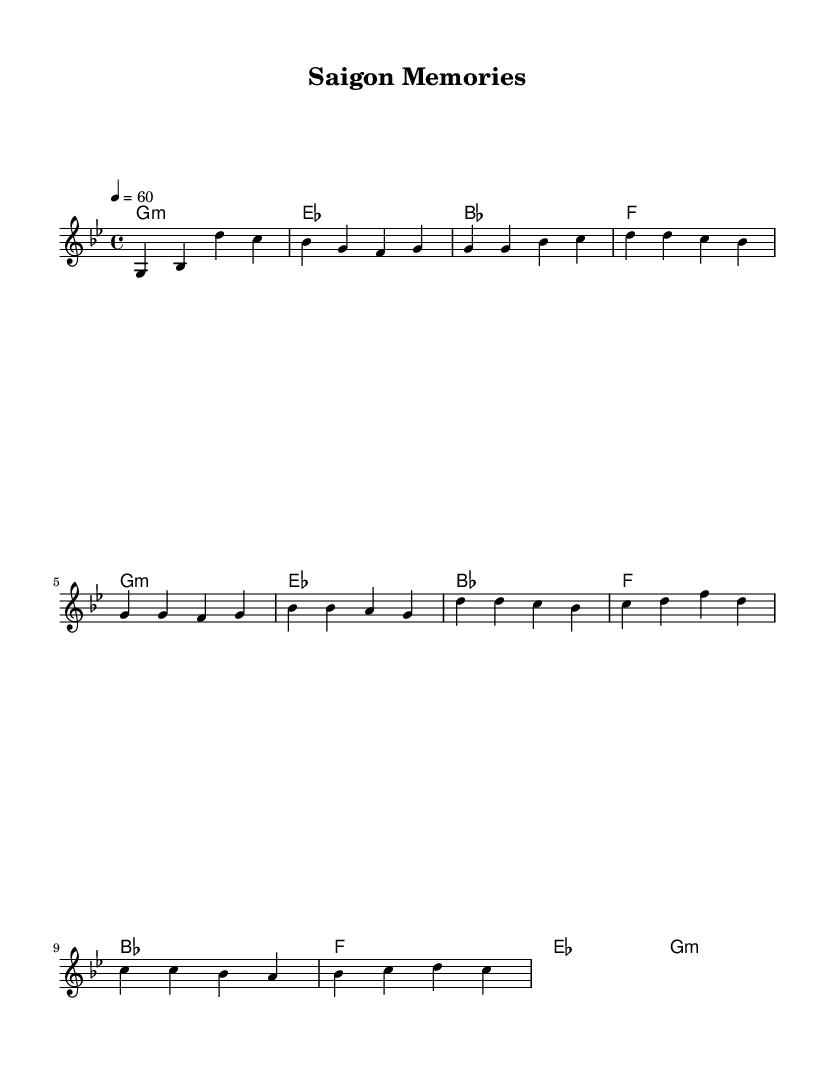What is the key signature of this music? The key signature is defined by the sharps or flats shown at the beginning of the sheet music. Here, the music is in G minor, as indicated by the two flats in the key signature.
Answer: G minor What is the time signature of this music? The time signature reveals how many beats are in each measure and which note value gets one beat. This music has a 4/4 time signature, indicated at the beginning, meaning there are four beats per measure.
Answer: 4/4 What is the tempo marking of the piece? The tempo marking shows the speed at which the music should be played. In this case, it is marked as 4 = 60, which indicates that a quarter note equals 60 beats per minute.
Answer: 60 How many measures are there in the first verse? By counting the individual measures in the partial verse provided, we can determine how many there are. The first verse contains eight measures.
Answer: 8 What type of chord is played in the introduction? The introduction chord is indicated in the harmonies section of the sheet music. The first chord is labeled as g minor, which is a minor chord.
Answer: g minor What is the highest note in the melody? To find the highest note in the melody line, I would look for the highest pitch represented in the notation. The highest note present is d', which indicates a D note in the octave above middle C.
Answer: d' What structural element is present in the music that is typical for soul ballads? Soul ballads often feature emotional and relatable lyrics, but when looking at the music structure, we can see a clear separation between verses and a chorus, which is typical for the genre. The presence of a chorus indicates this structure.
Answer: Chorus 